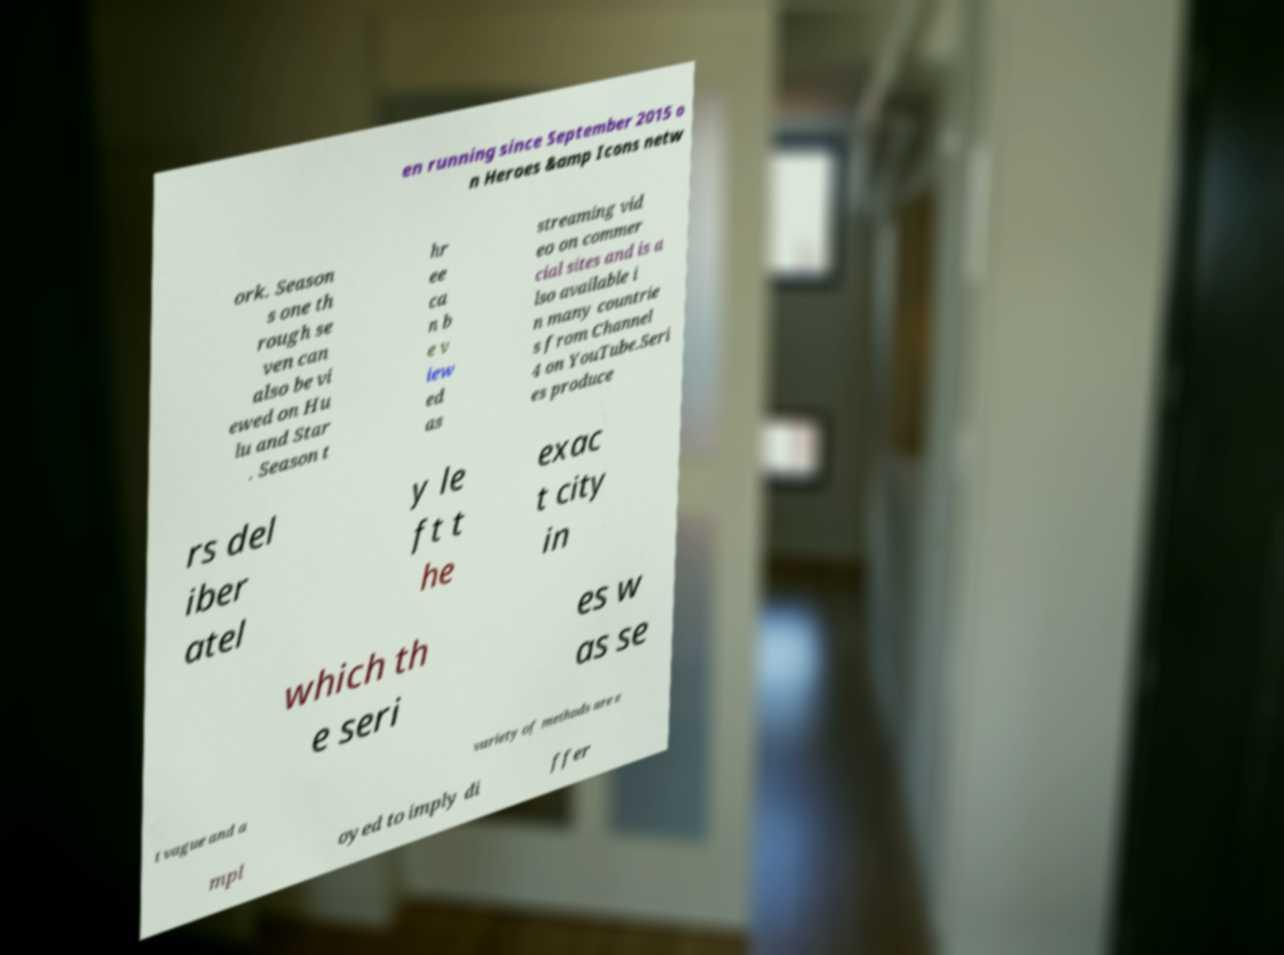What messages or text are displayed in this image? I need them in a readable, typed format. en running since September 2015 o n Heroes &amp Icons netw ork. Season s one th rough se ven can also be vi ewed on Hu lu and Star . Season t hr ee ca n b e v iew ed as streaming vid eo on commer cial sites and is a lso available i n many countrie s from Channel 4 on YouTube.Seri es produce rs del iber atel y le ft t he exac t city in which th e seri es w as se t vague and a variety of methods are e mpl oyed to imply di ffer 